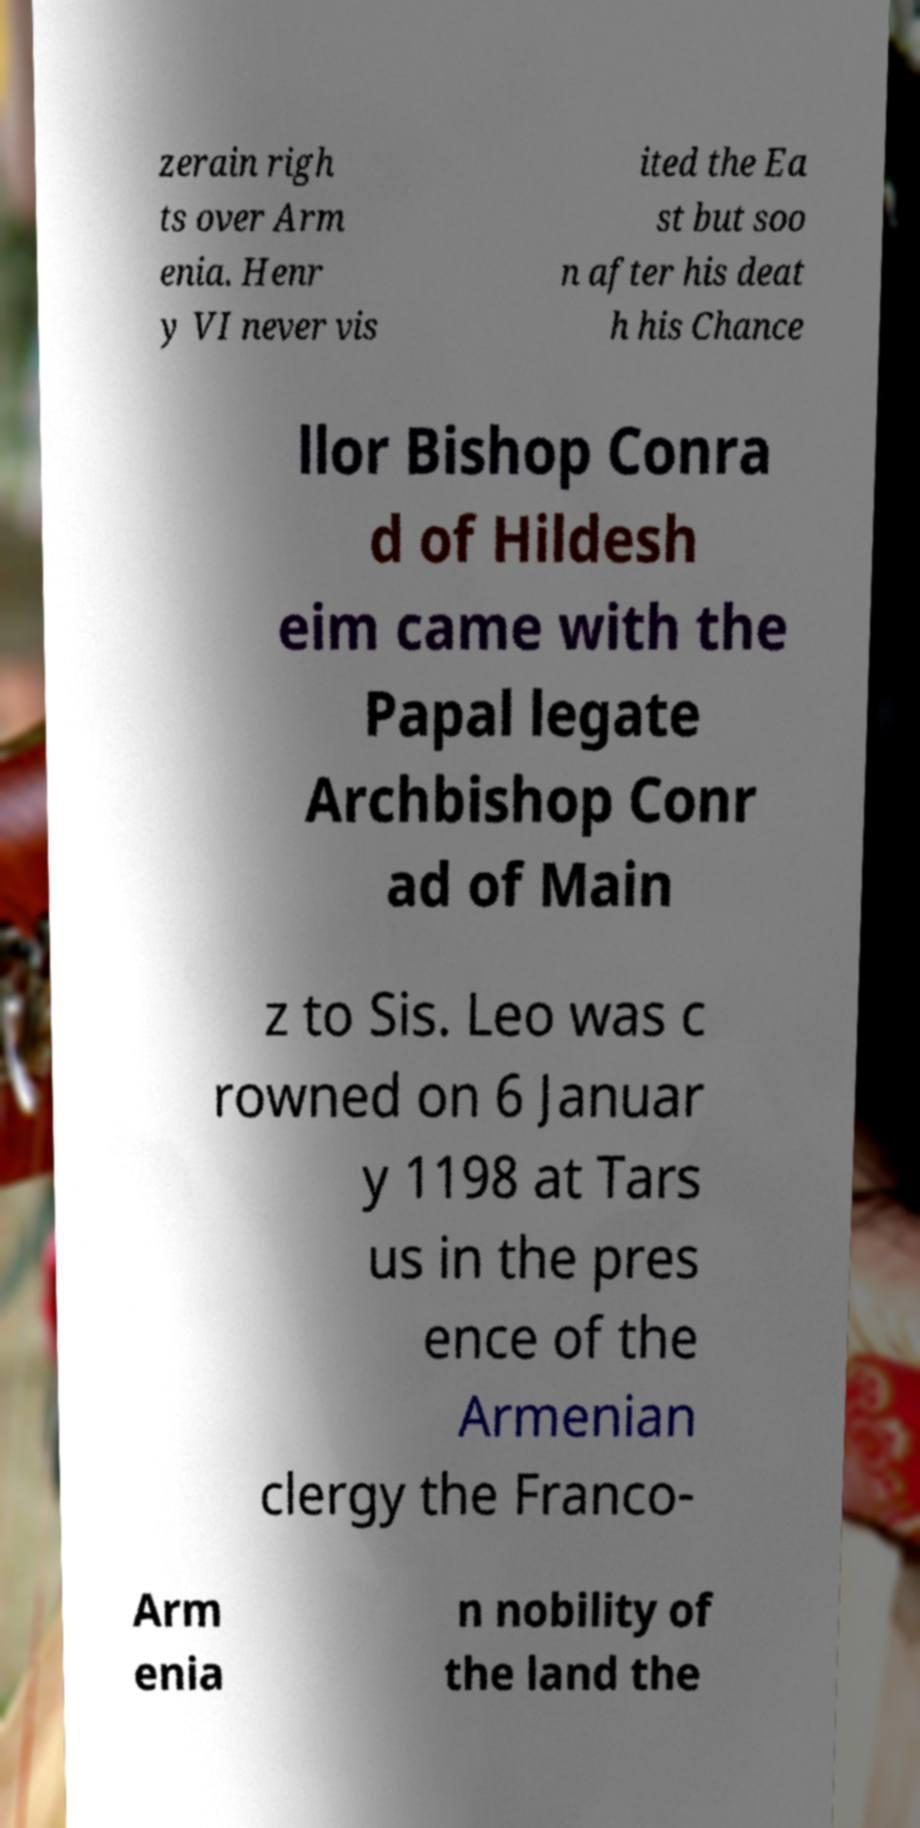For documentation purposes, I need the text within this image transcribed. Could you provide that? zerain righ ts over Arm enia. Henr y VI never vis ited the Ea st but soo n after his deat h his Chance llor Bishop Conra d of Hildesh eim came with the Papal legate Archbishop Conr ad of Main z to Sis. Leo was c rowned on 6 Januar y 1198 at Tars us in the pres ence of the Armenian clergy the Franco- Arm enia n nobility of the land the 